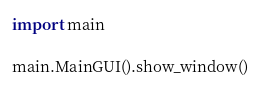Convert code to text. <code><loc_0><loc_0><loc_500><loc_500><_Python_>import main

main.MainGUI().show_window()</code> 